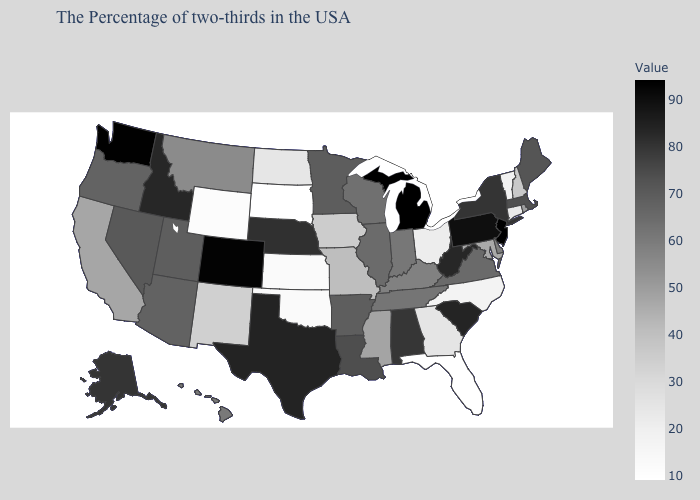Among the states that border Arizona , which have the lowest value?
Short answer required. New Mexico. Which states have the highest value in the USA?
Short answer required. New Jersey. Among the states that border Oklahoma , does Kansas have the highest value?
Be succinct. No. Is the legend a continuous bar?
Answer briefly. Yes. Does the map have missing data?
Give a very brief answer. No. Does Washington have the highest value in the West?
Quick response, please. Yes. Among the states that border Texas , does New Mexico have the highest value?
Be succinct. No. 